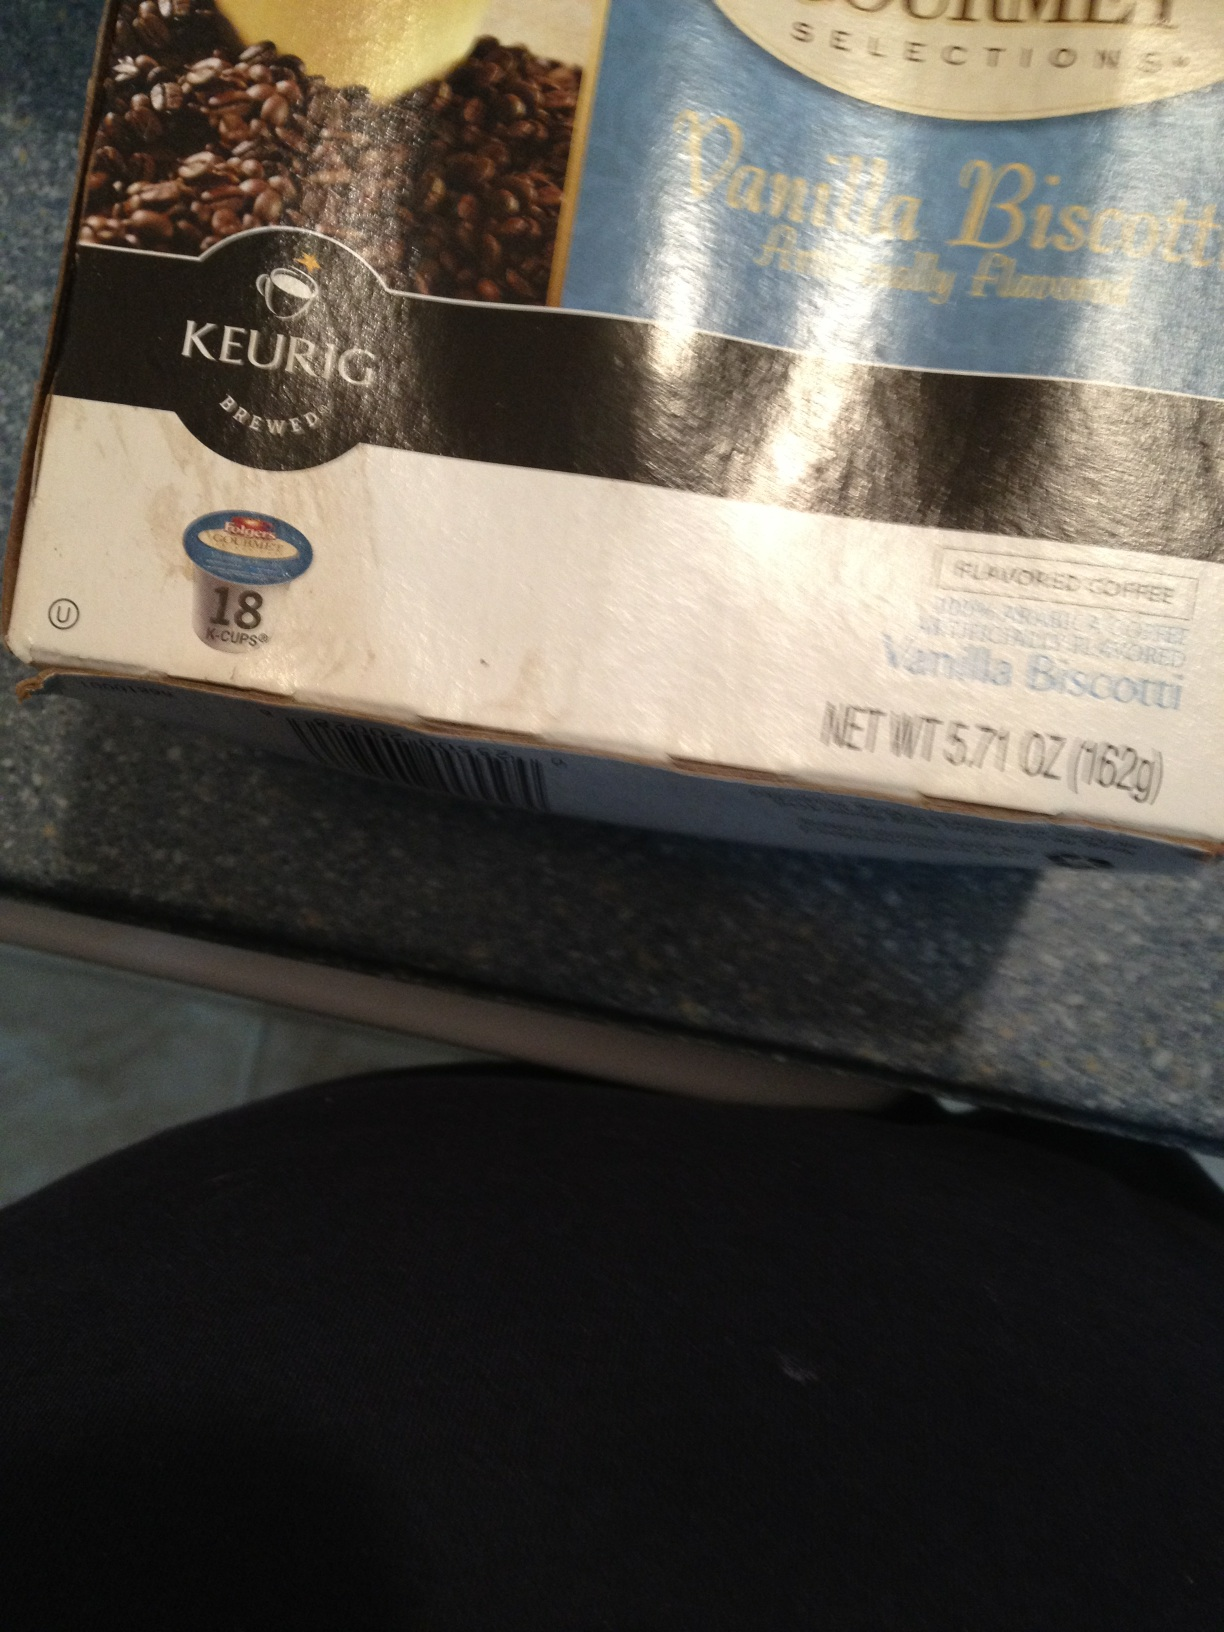Can you describe the packaging of the product? The packaging of the product features a predominantly black and white design with a blue accent. At the top, there is an image of coffee beans and a cup of coffee. The brand 'Keurig Brewed' is prominently displayed. The bottom section indicates that the package contains 18 K-Cups and has a net weight of 5.71 oz (162g). The flavor is clearly marked as 'Vanilla Biscotti.' 